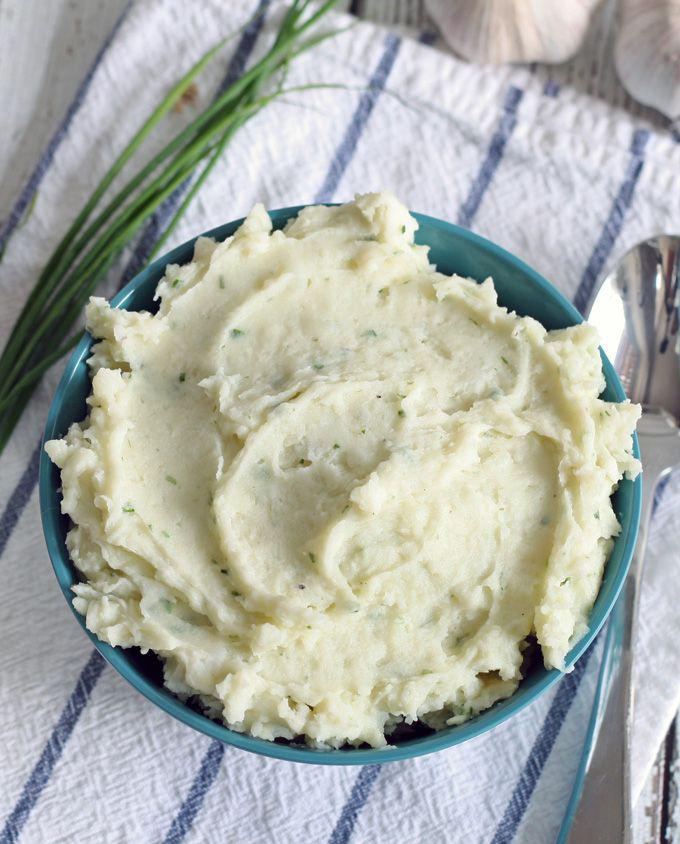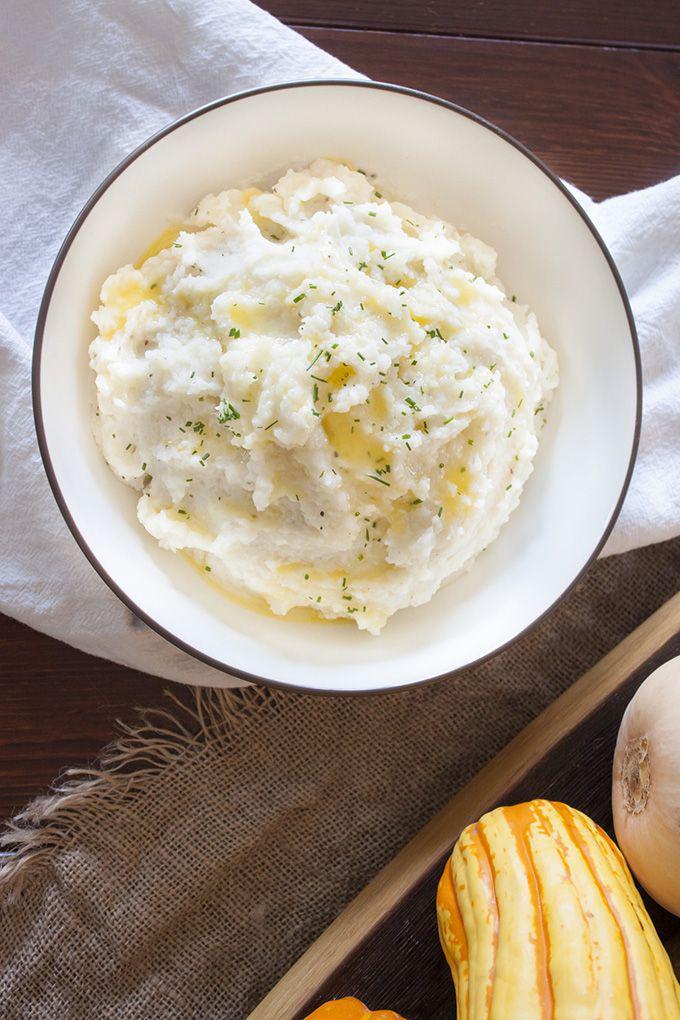The first image is the image on the left, the second image is the image on the right. Evaluate the accuracy of this statement regarding the images: "One image shows a bowl of mashed potatoes with no spoon near it.". Is it true? Answer yes or no. Yes. 